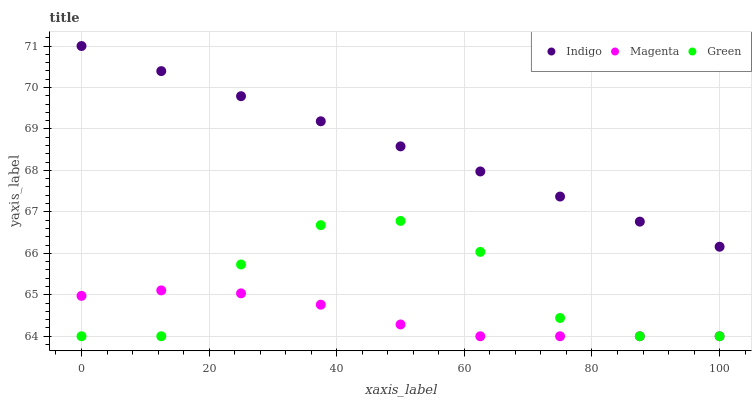Does Magenta have the minimum area under the curve?
Answer yes or no. Yes. Does Indigo have the maximum area under the curve?
Answer yes or no. Yes. Does Indigo have the minimum area under the curve?
Answer yes or no. No. Does Magenta have the maximum area under the curve?
Answer yes or no. No. Is Indigo the smoothest?
Answer yes or no. Yes. Is Green the roughest?
Answer yes or no. Yes. Is Magenta the smoothest?
Answer yes or no. No. Is Magenta the roughest?
Answer yes or no. No. Does Green have the lowest value?
Answer yes or no. Yes. Does Indigo have the lowest value?
Answer yes or no. No. Does Indigo have the highest value?
Answer yes or no. Yes. Does Magenta have the highest value?
Answer yes or no. No. Is Green less than Indigo?
Answer yes or no. Yes. Is Indigo greater than Magenta?
Answer yes or no. Yes. Does Magenta intersect Green?
Answer yes or no. Yes. Is Magenta less than Green?
Answer yes or no. No. Is Magenta greater than Green?
Answer yes or no. No. Does Green intersect Indigo?
Answer yes or no. No. 